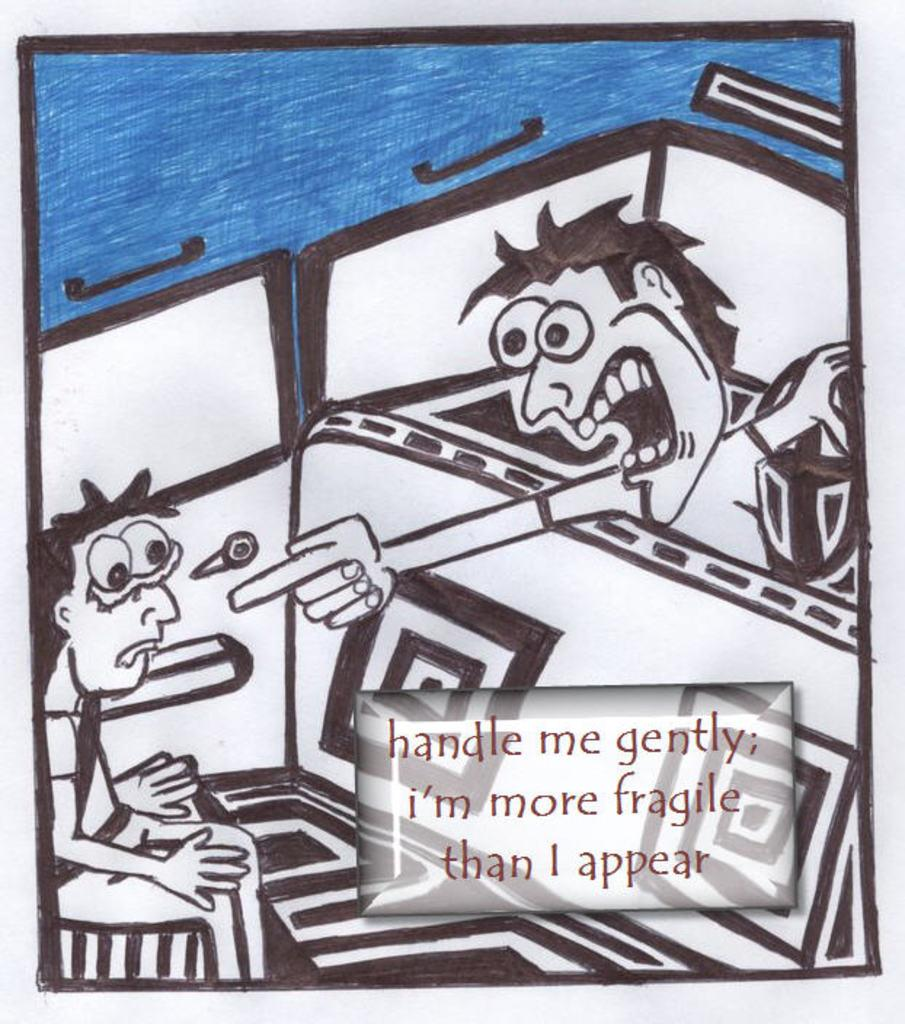<image>
Relay a brief, clear account of the picture shown. A picture shows a man pointing a finger at another man saying "handle me gently, I'm more fragile than I appear" 